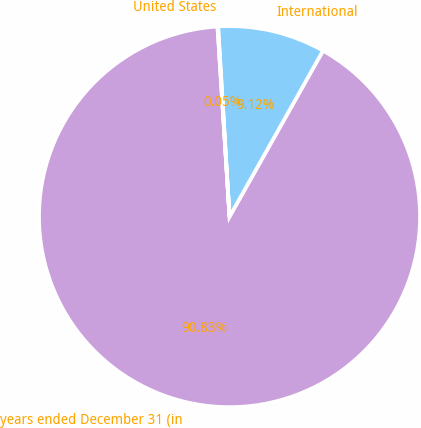<chart> <loc_0><loc_0><loc_500><loc_500><pie_chart><fcel>years ended December 31 (in<fcel>International<fcel>United States<nl><fcel>90.83%<fcel>9.12%<fcel>0.05%<nl></chart> 